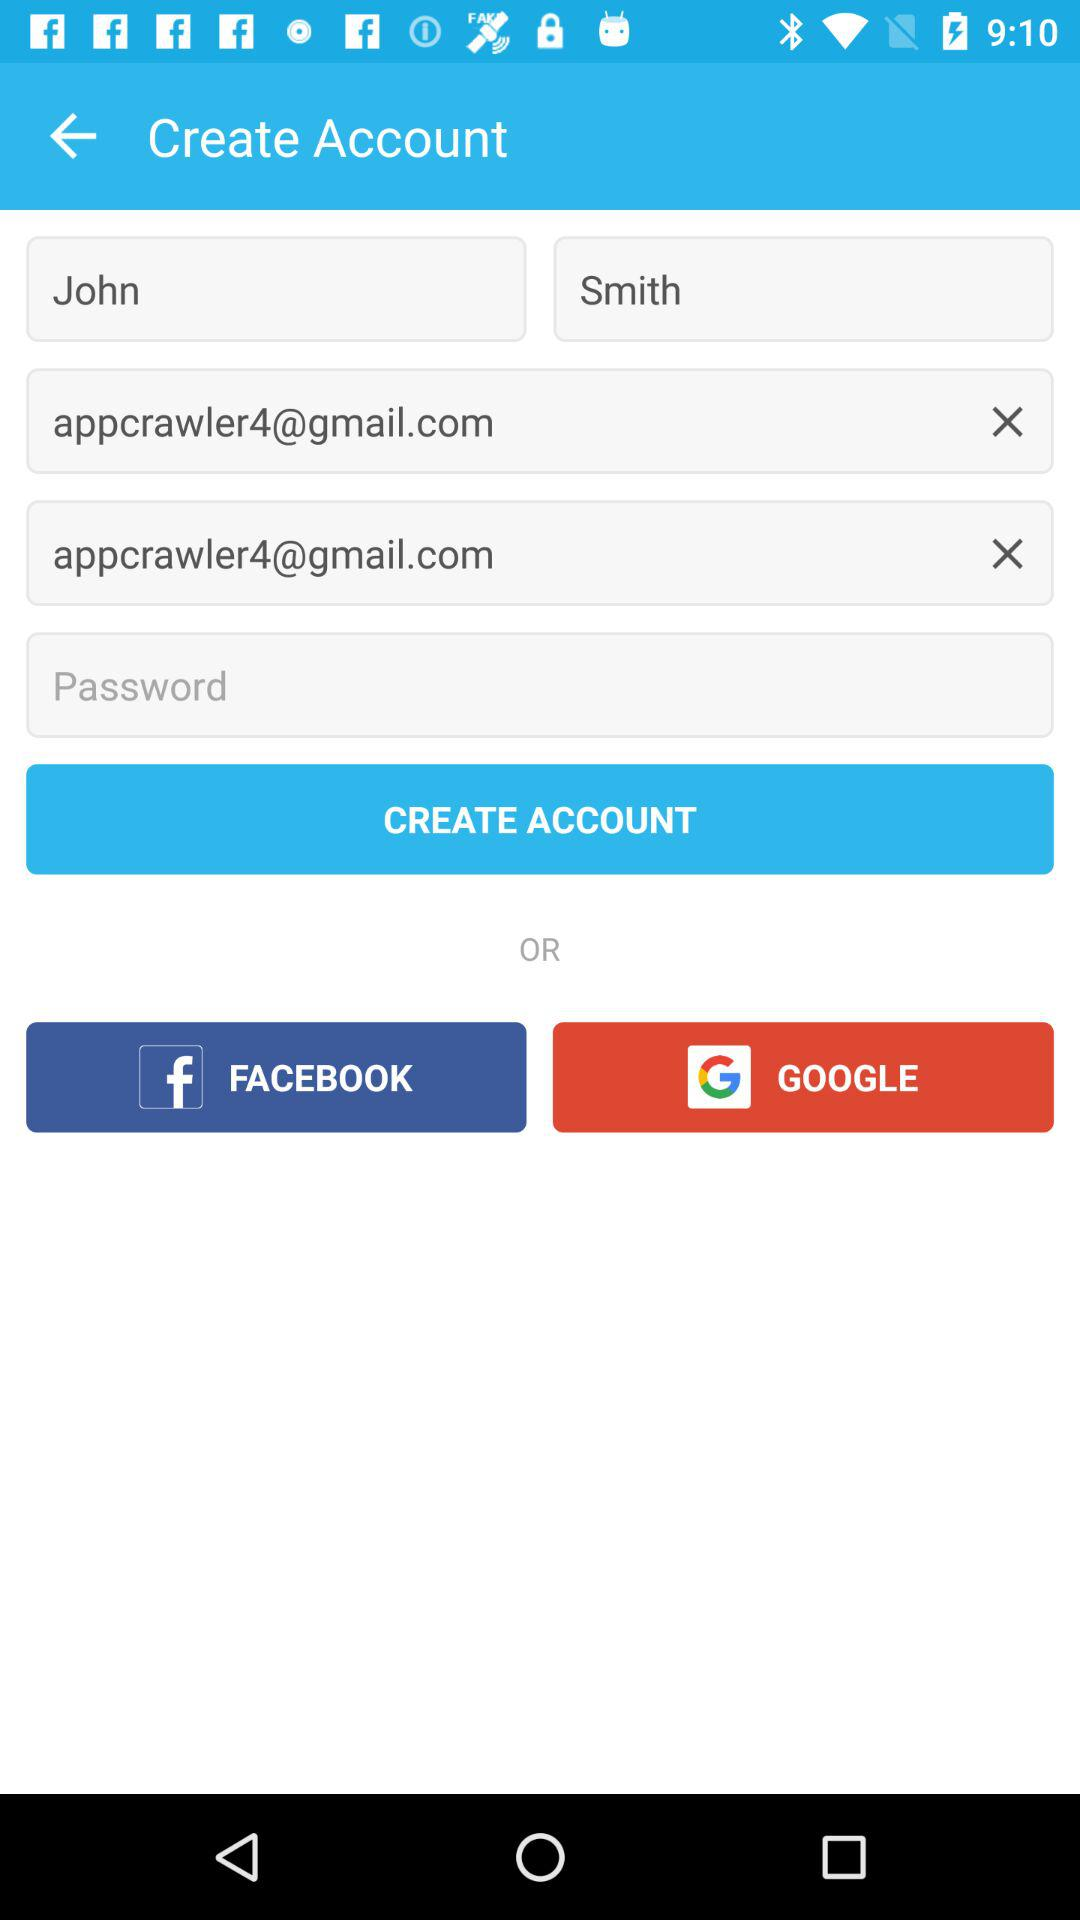How many text inputs have an email address?
Answer the question using a single word or phrase. 2 